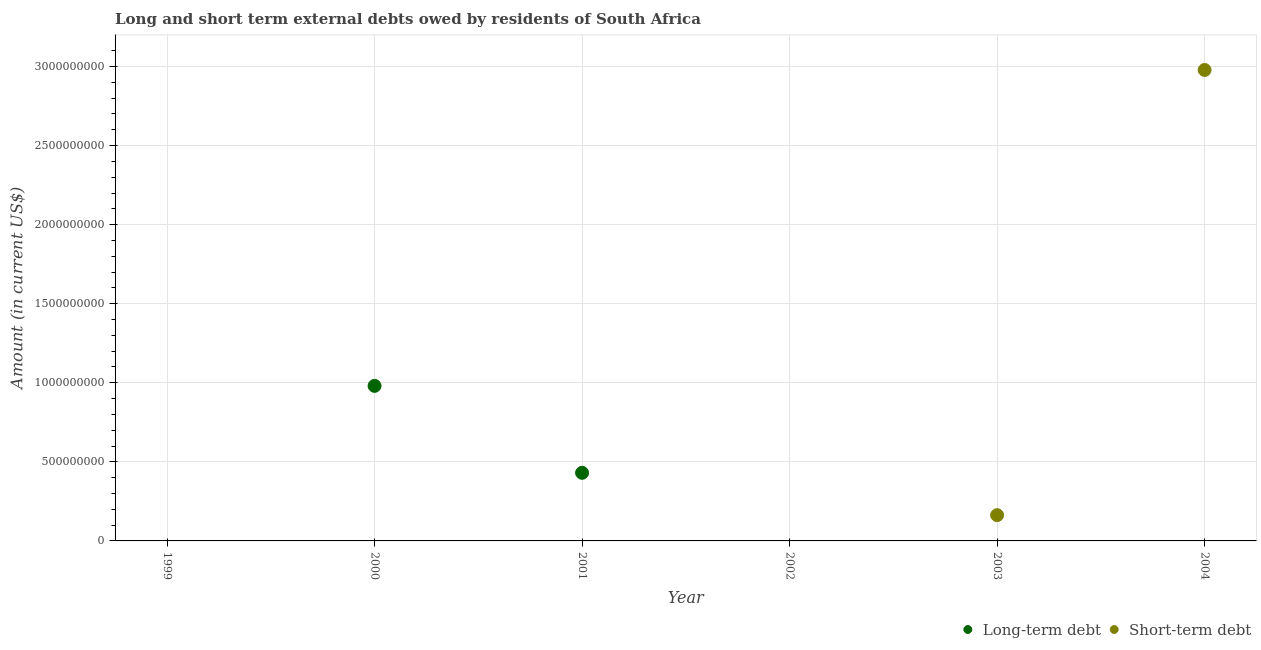Is the number of dotlines equal to the number of legend labels?
Your answer should be compact. No. What is the short-term debts owed by residents in 2003?
Provide a succinct answer. 1.63e+08. Across all years, what is the maximum long-term debts owed by residents?
Your response must be concise. 9.80e+08. What is the total long-term debts owed by residents in the graph?
Provide a short and direct response. 1.41e+09. What is the difference between the long-term debts owed by residents in 2000 and that in 2001?
Make the answer very short. 5.50e+08. What is the average short-term debts owed by residents per year?
Keep it short and to the point. 5.24e+08. In how many years, is the short-term debts owed by residents greater than 1200000000 US$?
Provide a short and direct response. 1. What is the difference between the highest and the lowest short-term debts owed by residents?
Give a very brief answer. 2.98e+09. In how many years, is the short-term debts owed by residents greater than the average short-term debts owed by residents taken over all years?
Keep it short and to the point. 1. How many years are there in the graph?
Offer a terse response. 6. What is the difference between two consecutive major ticks on the Y-axis?
Your response must be concise. 5.00e+08. Are the values on the major ticks of Y-axis written in scientific E-notation?
Offer a very short reply. No. Does the graph contain any zero values?
Keep it short and to the point. Yes. Does the graph contain grids?
Offer a very short reply. Yes. Where does the legend appear in the graph?
Provide a succinct answer. Bottom right. How many legend labels are there?
Provide a succinct answer. 2. What is the title of the graph?
Your answer should be very brief. Long and short term external debts owed by residents of South Africa. What is the label or title of the X-axis?
Offer a very short reply. Year. What is the label or title of the Y-axis?
Ensure brevity in your answer.  Amount (in current US$). What is the Amount (in current US$) of Short-term debt in 1999?
Provide a succinct answer. 0. What is the Amount (in current US$) of Long-term debt in 2000?
Provide a succinct answer. 9.80e+08. What is the Amount (in current US$) in Long-term debt in 2001?
Ensure brevity in your answer.  4.31e+08. What is the Amount (in current US$) of Short-term debt in 2001?
Offer a very short reply. 0. What is the Amount (in current US$) in Short-term debt in 2003?
Ensure brevity in your answer.  1.63e+08. What is the Amount (in current US$) of Long-term debt in 2004?
Give a very brief answer. 0. What is the Amount (in current US$) of Short-term debt in 2004?
Your answer should be compact. 2.98e+09. Across all years, what is the maximum Amount (in current US$) in Long-term debt?
Keep it short and to the point. 9.80e+08. Across all years, what is the maximum Amount (in current US$) in Short-term debt?
Your response must be concise. 2.98e+09. Across all years, what is the minimum Amount (in current US$) in Long-term debt?
Your response must be concise. 0. What is the total Amount (in current US$) of Long-term debt in the graph?
Make the answer very short. 1.41e+09. What is the total Amount (in current US$) in Short-term debt in the graph?
Your response must be concise. 3.14e+09. What is the difference between the Amount (in current US$) in Long-term debt in 2000 and that in 2001?
Offer a very short reply. 5.50e+08. What is the difference between the Amount (in current US$) of Short-term debt in 2003 and that in 2004?
Offer a very short reply. -2.82e+09. What is the difference between the Amount (in current US$) in Long-term debt in 2000 and the Amount (in current US$) in Short-term debt in 2003?
Offer a very short reply. 8.17e+08. What is the difference between the Amount (in current US$) of Long-term debt in 2000 and the Amount (in current US$) of Short-term debt in 2004?
Your answer should be compact. -2.00e+09. What is the difference between the Amount (in current US$) of Long-term debt in 2001 and the Amount (in current US$) of Short-term debt in 2003?
Offer a terse response. 2.68e+08. What is the difference between the Amount (in current US$) of Long-term debt in 2001 and the Amount (in current US$) of Short-term debt in 2004?
Offer a terse response. -2.55e+09. What is the average Amount (in current US$) of Long-term debt per year?
Your answer should be very brief. 2.35e+08. What is the average Amount (in current US$) in Short-term debt per year?
Offer a terse response. 5.24e+08. What is the ratio of the Amount (in current US$) in Long-term debt in 2000 to that in 2001?
Your answer should be compact. 2.28. What is the ratio of the Amount (in current US$) in Short-term debt in 2003 to that in 2004?
Give a very brief answer. 0.05. What is the difference between the highest and the lowest Amount (in current US$) in Long-term debt?
Your answer should be very brief. 9.80e+08. What is the difference between the highest and the lowest Amount (in current US$) in Short-term debt?
Your answer should be very brief. 2.98e+09. 